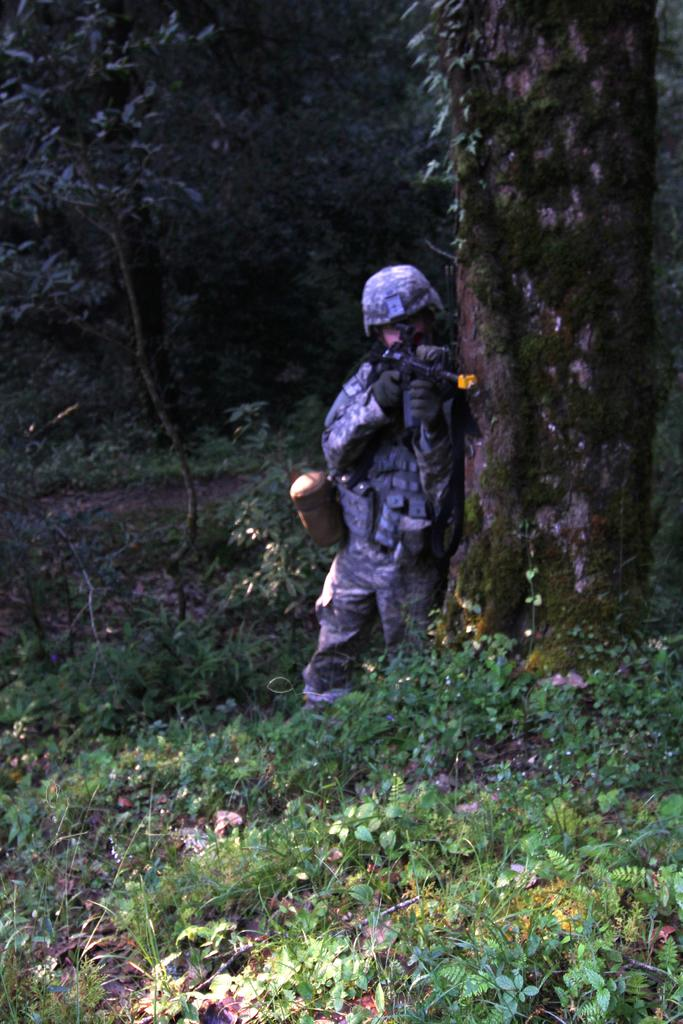What is the main subject of the image? There is a person in the image. What type of clothing is the person wearing? The person is wearing a uniform, helmet, and gloves. What is the person holding in the image? The person is holding a weapon. Where is the person standing in relation to the tree trunk? The person is standing near a tree trunk. What can be seen in the background of the image? There are plants and trees in the background of the image. What flavor of giraffe can be seen in the image? There is no giraffe present in the image, and therefore no flavor can be determined. What color is the sky in the image? The provided facts do not mention the color of the sky, so it cannot be determined from the image. 